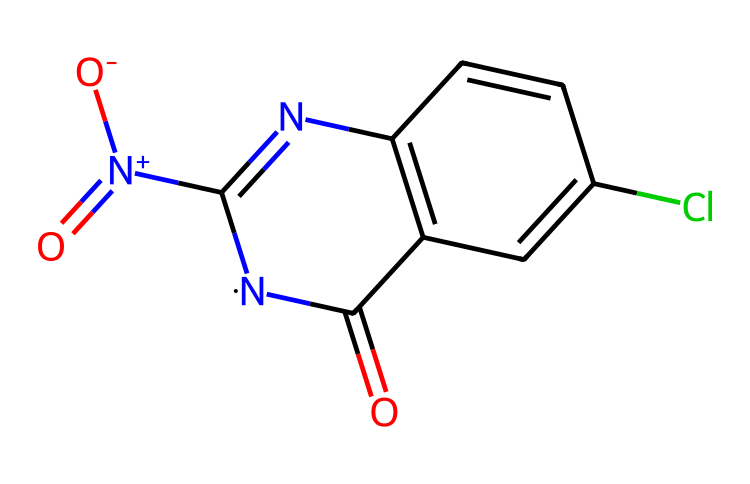What is the molecular formula of this chemical? By analyzing the SMILES provided, we can count the number of each type of atom present: there is 1 carbon in the amide bond, 5 other carbons in the aromatic ring, 2 nitrogens in the nitrogen moieties, 1 oxygen for the amide carbonyl, 2 oxygens for the nitro group, and 1 chlorine. Adding these up provides the molecular formula C7H6ClN4O3.
Answer: C7H6ClN4O3 How many nitrogen atoms are present in this structure? The SMILES representation indicates two distinct nitrogen atoms, one from the -N- part of the ring and another from the -N+(=O)[O-] indicating a quaternary nitrogen associated with a nitro group. Thus, the total count is 4 nitrogen atoms.
Answer: 4 What type of chemical is represented by this structure? This structure depicts a neonicotinoid, identifiable by its nitrogen heterocycles and the presence of a nitro group, which are characteristic of the class of insecticides designed to affect the nervous system of insects.
Answer: neonicotinoid What is the role of the nitro group in this compound? The nitro group (-N+(=O)[O-]) enhances the chemical's insecticidal potency by acting on the nicotinic acetylcholine receptors in insects, facilitating enhanced binding and leading to neurotoxicity.
Answer: insecticidal potency Describe the significance of the chlorine atom in this chemical. The chlorine substituent on the aromatic ring contributes to the overall hydrophobic character of the molecule, which aids in the chemical's ability to penetrate biological membranes and enhances its effectiveness as an insecticide.
Answer: enhances effectiveness Which part of this chemical is responsible for its neurotoxic effects? The region including the nitrogen atoms in the rings and the nitro group is responsible for reactivity with nicotinic acetylcholine receptors, which leads to neurotoxic effects, disrupting normal nerve signal transmission.
Answer: nitrogen and nitro group 